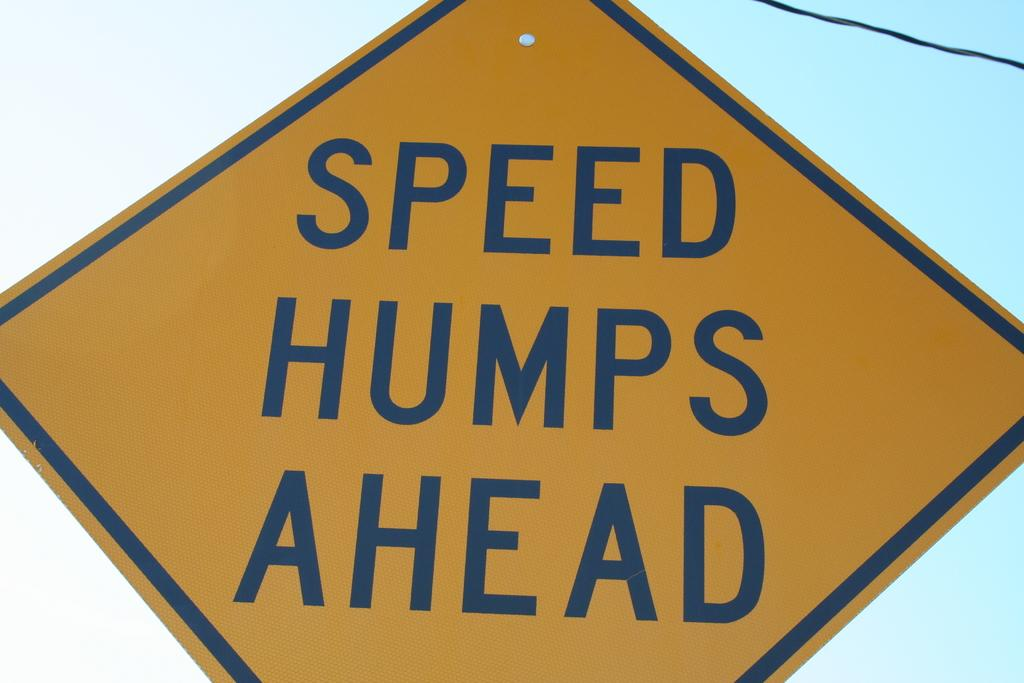<image>
Provide a brief description of the given image. speed bumps ahead is written on a street sign 